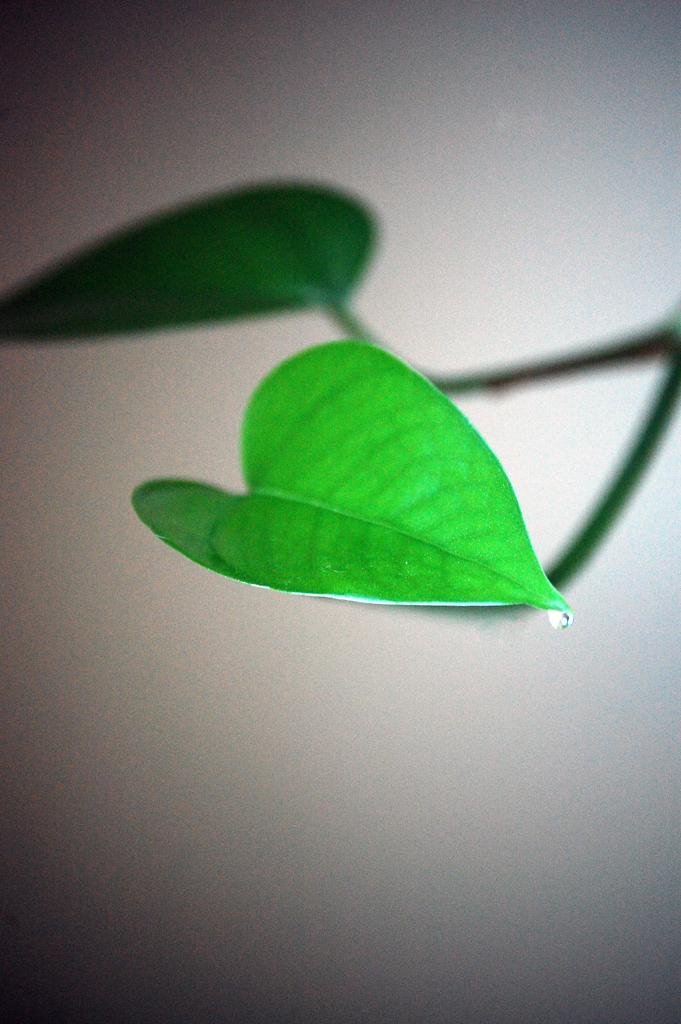What is on the green leaf in the image? There is a water drop on a green leaf in the image. What type of plant does the leaf belong to? The leaf belongs to a plant, but the specific type of plant is not mentioned in the facts. How would you describe the background of the image? The background has a white and gray color combination. How many sisters are playing with the dogs on the floor in the image? There are no sisters, dogs, or floor present in the image. The image only features a water drop on a green leaf with a white and gray background. 